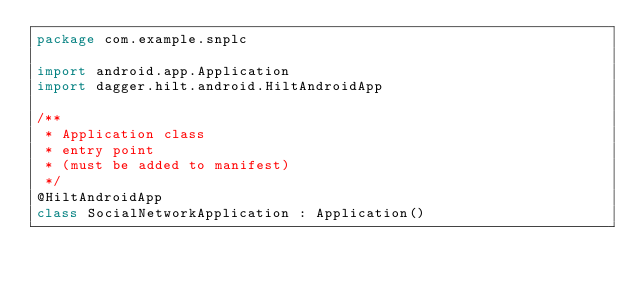Convert code to text. <code><loc_0><loc_0><loc_500><loc_500><_Kotlin_>package com.example.snplc

import android.app.Application
import dagger.hilt.android.HiltAndroidApp

/**
 * Application class
 * entry point
 * (must be added to manifest)
 */
@HiltAndroidApp
class SocialNetworkApplication : Application()</code> 